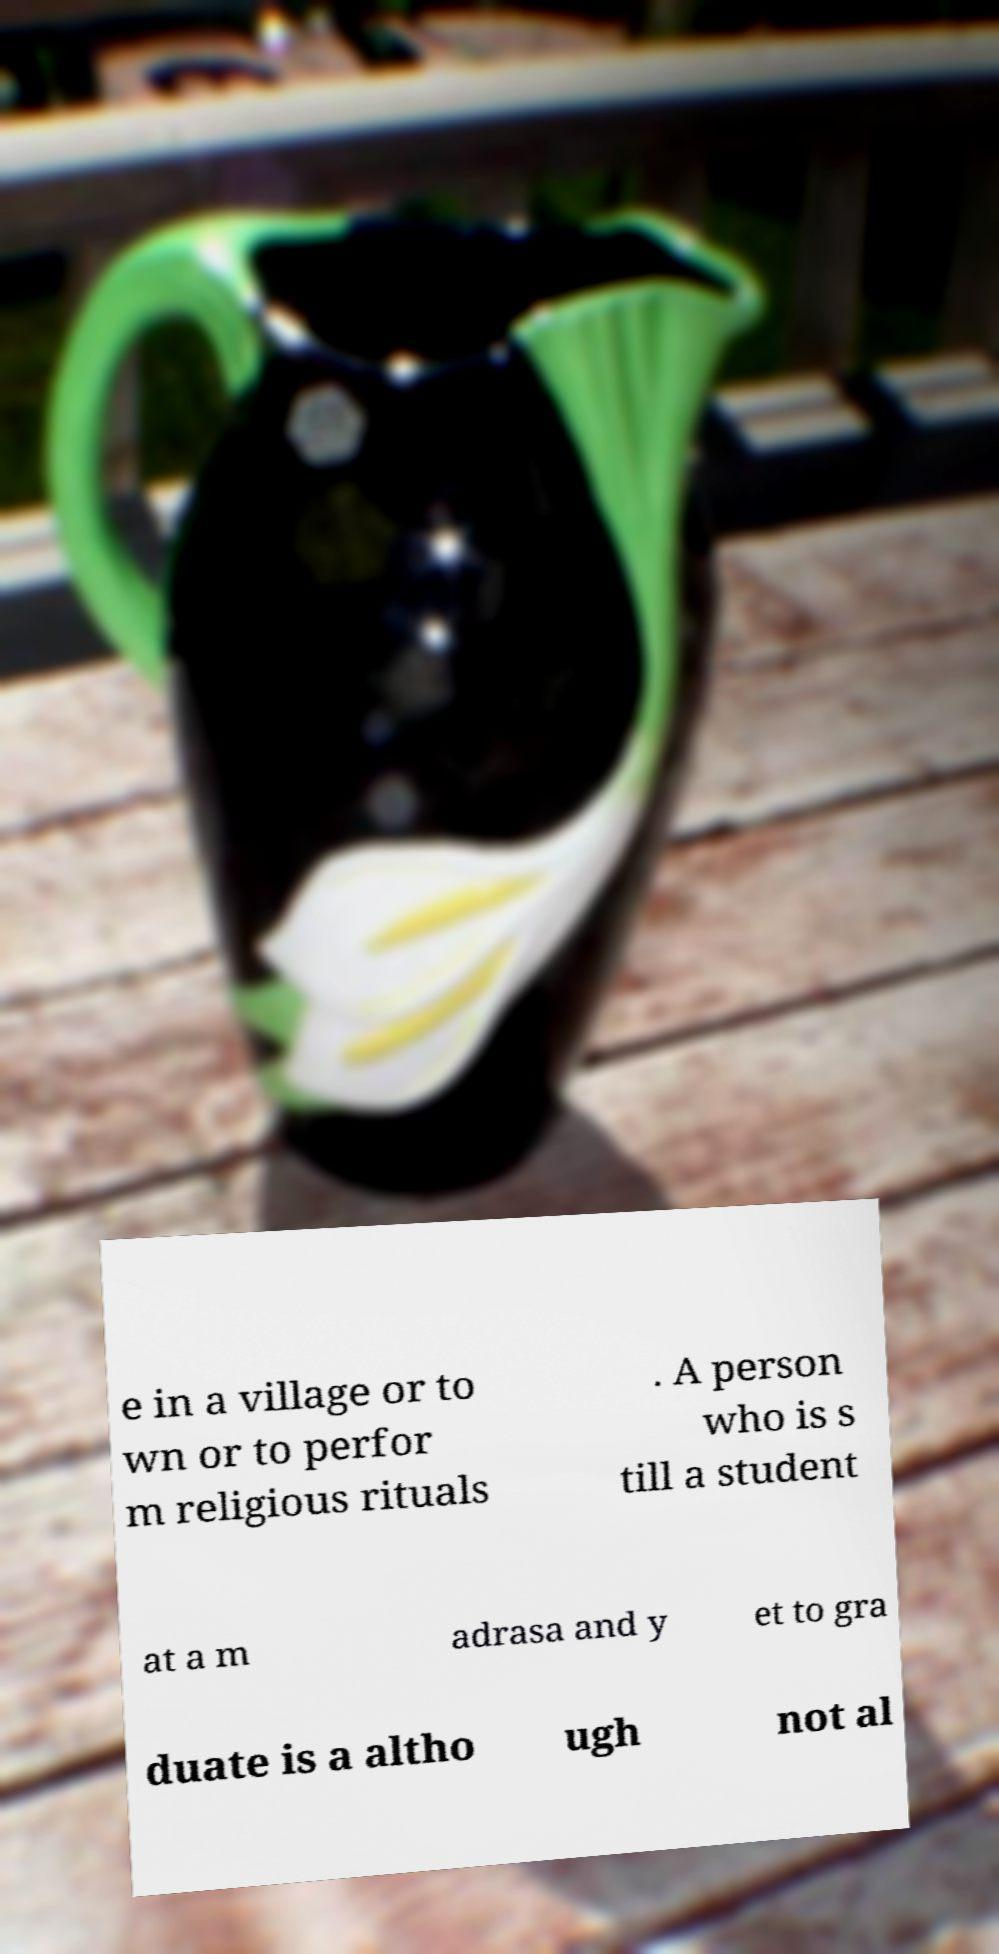I need the written content from this picture converted into text. Can you do that? e in a village or to wn or to perfor m religious rituals . A person who is s till a student at a m adrasa and y et to gra duate is a altho ugh not al 